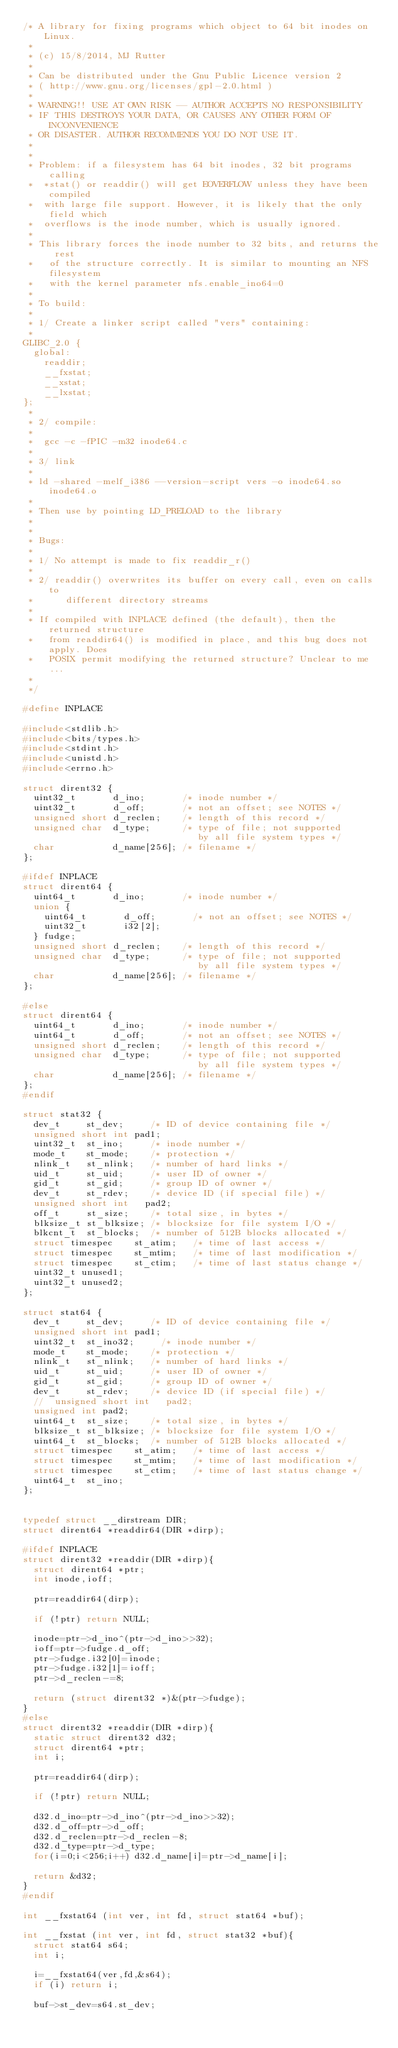Convert code to text. <code><loc_0><loc_0><loc_500><loc_500><_C_>/* A library for fixing programs which object to 64 bit inodes on Linux.
 *
 * (c) 15/8/2014, MJ Rutter
 *
 * Can be distributed under the Gnu Public Licence version 2
 * ( http://www.gnu.org/licenses/gpl-2.0.html )
 *
 * WARNING!! USE AT OWN RISK -- AUTHOR ACCEPTS NO RESPONSIBILITY
 * IF THIS DESTROYS YOUR DATA, OR CAUSES ANY OTHER FORM OF INCONVENIENCE
 * OR DISASTER. AUTHOR RECOMMENDS YOU DO NOT USE IT.
 * 
 *
 * Problem: if a filesystem has 64 bit inodes, 32 bit programs calling
 *  *stat() or readdir() will get EOVERFLOW unless they have been compiled
 *  with large file support. However, it is likely that the only field which
 *  overflows is the inode number, which is usually ignored.
 *
 * This library forces the inode number to 32 bits, and returns the rest
 *   of the structure correctly. It is similar to mounting an NFS filesystem
 *   with the kernel parameter nfs.enable_ino64=0
 *
 * To build:
 *
 * 1/ Create a linker script called "vers" containing:
 *
GLIBC_2.0 {
  global:
    readdir;
    __fxstat;
    __xstat;
    __lxstat;
};
 *
 * 2/ compile: 
 *
 *  gcc -c -fPIC -m32 inode64.c
 *
 * 3/ link
 *
 * ld -shared -melf_i386 --version-script vers -o inode64.so inode64.o
 *
 * Then use by pointing LD_PRELOAD to the library
 *
 *
 * Bugs:
 *
 * 1/ No attempt is made to fix readdir_r()
 *
 * 2/ readdir() overwrites its buffer on every call, even on calls to
 *      different directory streams
 *
 * If compiled with INPLACE defined (the default), then the returned structure
 *   from readdir64() is modified in place, and this bug does not apply. Does
 *   POSIX permit modifying the returned structure? Unclear to me...
 *
 */

#define INPLACE

#include<stdlib.h>
#include<bits/types.h>
#include<stdint.h>
#include<unistd.h>
#include<errno.h>

struct dirent32 {
  uint32_t       d_ino;       /* inode number */
  uint32_t       d_off;       /* not an offset; see NOTES */
  unsigned short d_reclen;    /* length of this record */
  unsigned char  d_type;      /* type of file; not supported
                                 by all file system types */
  char           d_name[256]; /* filename */
};

#ifdef INPLACE
struct dirent64 {
  uint64_t       d_ino;       /* inode number */
  union {
    uint64_t       d_off;       /* not an offset; see NOTES */
    uint32_t       i32[2];
  } fudge;
  unsigned short d_reclen;    /* length of this record */
  unsigned char  d_type;      /* type of file; not supported
                                 by all file system types */
  char           d_name[256]; /* filename */
};

#else
struct dirent64 {
  uint64_t       d_ino;       /* inode number */
  uint64_t       d_off;       /* not an offset; see NOTES */
  unsigned short d_reclen;    /* length of this record */
  unsigned char  d_type;      /* type of file; not supported
                                 by all file system types */
  char           d_name[256]; /* filename */
};
#endif

struct stat32 {
  dev_t     st_dev;     /* ID of device containing file */
  unsigned short int pad1;
  uint32_t  st_ino;     /* inode number */
  mode_t    st_mode;    /* protection */
  nlink_t   st_nlink;   /* number of hard links */
  uid_t     st_uid;     /* user ID of owner */
  gid_t     st_gid;     /* group ID of owner */
  dev_t     st_rdev;    /* device ID (if special file) */
  unsigned short int   pad2;
  off_t     st_size;    /* total size, in bytes */
  blksize_t st_blksize; /* blocksize for file system I/O */
  blkcnt_t  st_blocks;  /* number of 512B blocks allocated */
  struct timespec    st_atim;   /* time of last access */
  struct timespec    st_mtim;   /* time of last modification */
  struct timespec    st_ctim;   /* time of last status change */
  uint32_t unused1;
  uint32_t unused2;
};

struct stat64 {
  dev_t     st_dev;     /* ID of device containing file */
  unsigned short int pad1;
  uint32_t  st_ino32;     /* inode number */
  mode_t    st_mode;    /* protection */
  nlink_t   st_nlink;   /* number of hard links */
  uid_t     st_uid;     /* user ID of owner */
  gid_t     st_gid;     /* group ID of owner */
  dev_t     st_rdev;    /* device ID (if special file) */
  //  unsigned short int   pad2;
  unsigned int pad2;
  uint64_t  st_size;    /* total size, in bytes */
  blksize_t st_blksize; /* blocksize for file system I/O */
  uint64_t  st_blocks;  /* number of 512B blocks allocated */
  struct timespec    st_atim;   /* time of last access */
  struct timespec    st_mtim;   /* time of last modification */
  struct timespec    st_ctim;   /* time of last status change */
  uint64_t  st_ino;
};


typedef struct __dirstream DIR;
struct dirent64 *readdir64(DIR *dirp);

#ifdef INPLACE
struct dirent32 *readdir(DIR *dirp){
  struct dirent64 *ptr;
  int inode,ioff;

  ptr=readdir64(dirp);

  if (!ptr) return NULL;

  inode=ptr->d_ino^(ptr->d_ino>>32);
  ioff=ptr->fudge.d_off;
  ptr->fudge.i32[0]=inode;
  ptr->fudge.i32[1]=ioff;
  ptr->d_reclen-=8;

  return (struct dirent32 *)&(ptr->fudge);
}
#else
struct dirent32 *readdir(DIR *dirp){
  static struct dirent32 d32;
  struct dirent64 *ptr;
  int i;

  ptr=readdir64(dirp);

  if (!ptr) return NULL;

  d32.d_ino=ptr->d_ino^(ptr->d_ino>>32);
  d32.d_off=ptr->d_off;
  d32.d_reclen=ptr->d_reclen-8;
  d32.d_type=ptr->d_type;
  for(i=0;i<256;i++) d32.d_name[i]=ptr->d_name[i];

  return &d32;
}
#endif

int __fxstat64 (int ver, int fd, struct stat64 *buf);

int __fxstat (int ver, int fd, struct stat32 *buf){
  struct stat64 s64;
  int i;

  i=__fxstat64(ver,fd,&s64);
  if (i) return i;

  buf->st_dev=s64.st_dev;</code> 